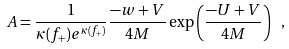<formula> <loc_0><loc_0><loc_500><loc_500>A = \frac { 1 } { \kappa ( f _ { + } ) e ^ { \kappa ( f _ { + } ) } } \frac { - w + V } { 4 M } \exp \left ( \frac { - U + V } { 4 M } \right ) \ ,</formula> 